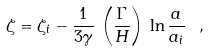Convert formula to latex. <formula><loc_0><loc_0><loc_500><loc_500>\zeta = \zeta _ { i } - \frac { 1 } { 3 \gamma } \, \left ( \frac { \Gamma } { H } \right ) ^ { } \, \ln { \frac { a } { a _ { i } } } \ ,</formula> 